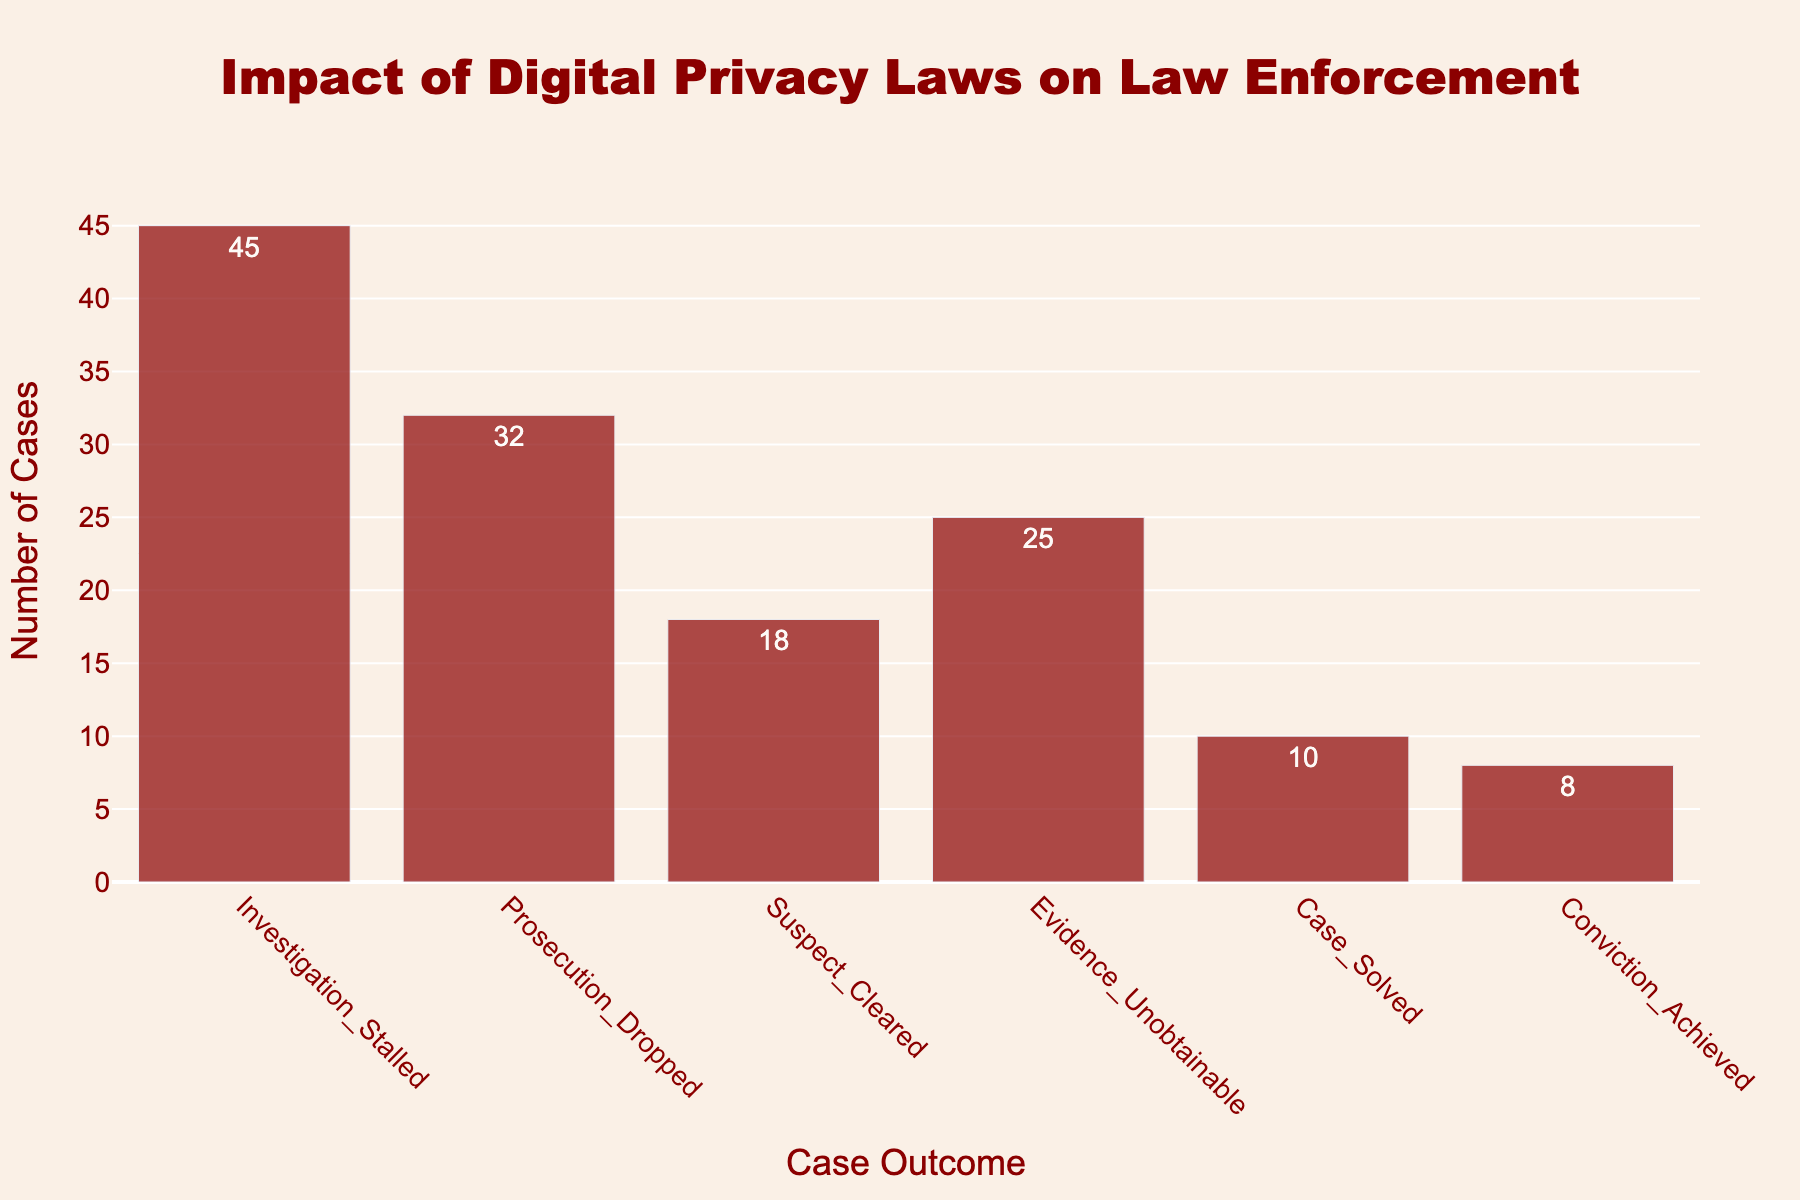What's the title of the figure? The title can be found at the top of the figure.
Answer: Impact of Digital Privacy Laws on Law Enforcement What's the color of the bars? By observing the color of the bars in the figure, it's clear that they all have the same color.
Answer: Dark red How many case outcomes are shown in the figure? The total number of distinct bars corresponds to the number of case outcomes shown. Count them.
Answer: Six Which case outcome has the highest count? To determine this, examine the heights of the bars and identify the tallest one.
Answer: Investigation Stalled Which case outcome has the lowest count? Identify the shortest bar among the ones displayed in the figure.
Answer: Conviction Achieved What is the total number of cases considered in the figure? Sum the counts of all the case outcomes: 45 + 32 + 18 + 25 + 10 + 8 = 138
Answer: 138 How many more cases resulted in 'Investigation Stalled' than 'Conviction Achieved'? Subtract the count of 'Conviction Achieved' from 'Investigation Stalled': 45 - 8 = 37
Answer: 37 Which case outcome(s) have counts greater than 'Evidence Unobtainable'? Compare the counts of 'Evidence Unobtainable' with the other outcomes and list those which are higher: 45, 32
Answer: Investigation Stalled, Prosecution Dropped What is the average count across all case outcomes? Calculate the sum of all counts and divide by the number of outcomes: (45 + 32 + 18 + 25 + 10 + 8) / 6 = 23
Answer: 23 Are there more cases where the investigation stalled or where prosecution was dropped? Compare the counts directly: 45 (Investigation Stalled) vs. 32 (Prosecution Dropped)
Answer: Investigation Stalled 